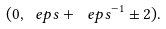Convert formula to latex. <formula><loc_0><loc_0><loc_500><loc_500>( 0 , \ e p s + \ e p s ^ { - 1 } \pm 2 ) .</formula> 